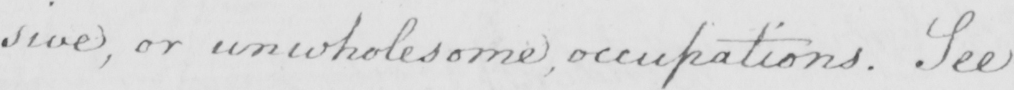Please provide the text content of this handwritten line. :sive, or unwholesome, occupations. See 